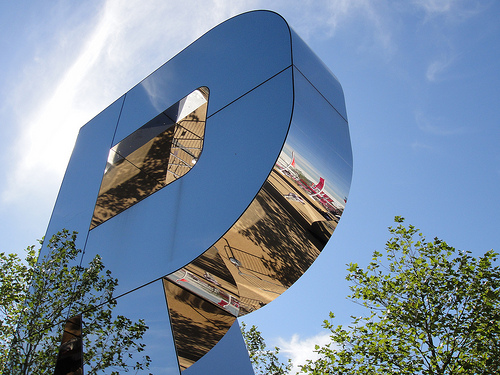<image>
Is the letter under the sky? Yes. The letter is positioned underneath the sky, with the sky above it in the vertical space. Is the silver in the sky? No. The silver is not contained within the sky. These objects have a different spatial relationship. 